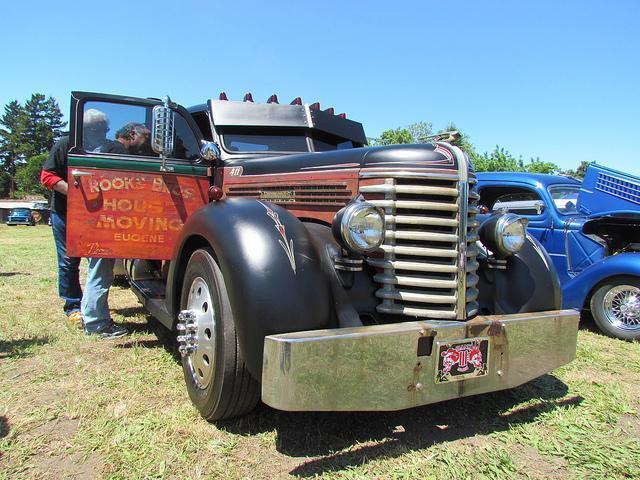How many people are there?
Give a very brief answer. 2. How many trucks are there?
Give a very brief answer. 2. 